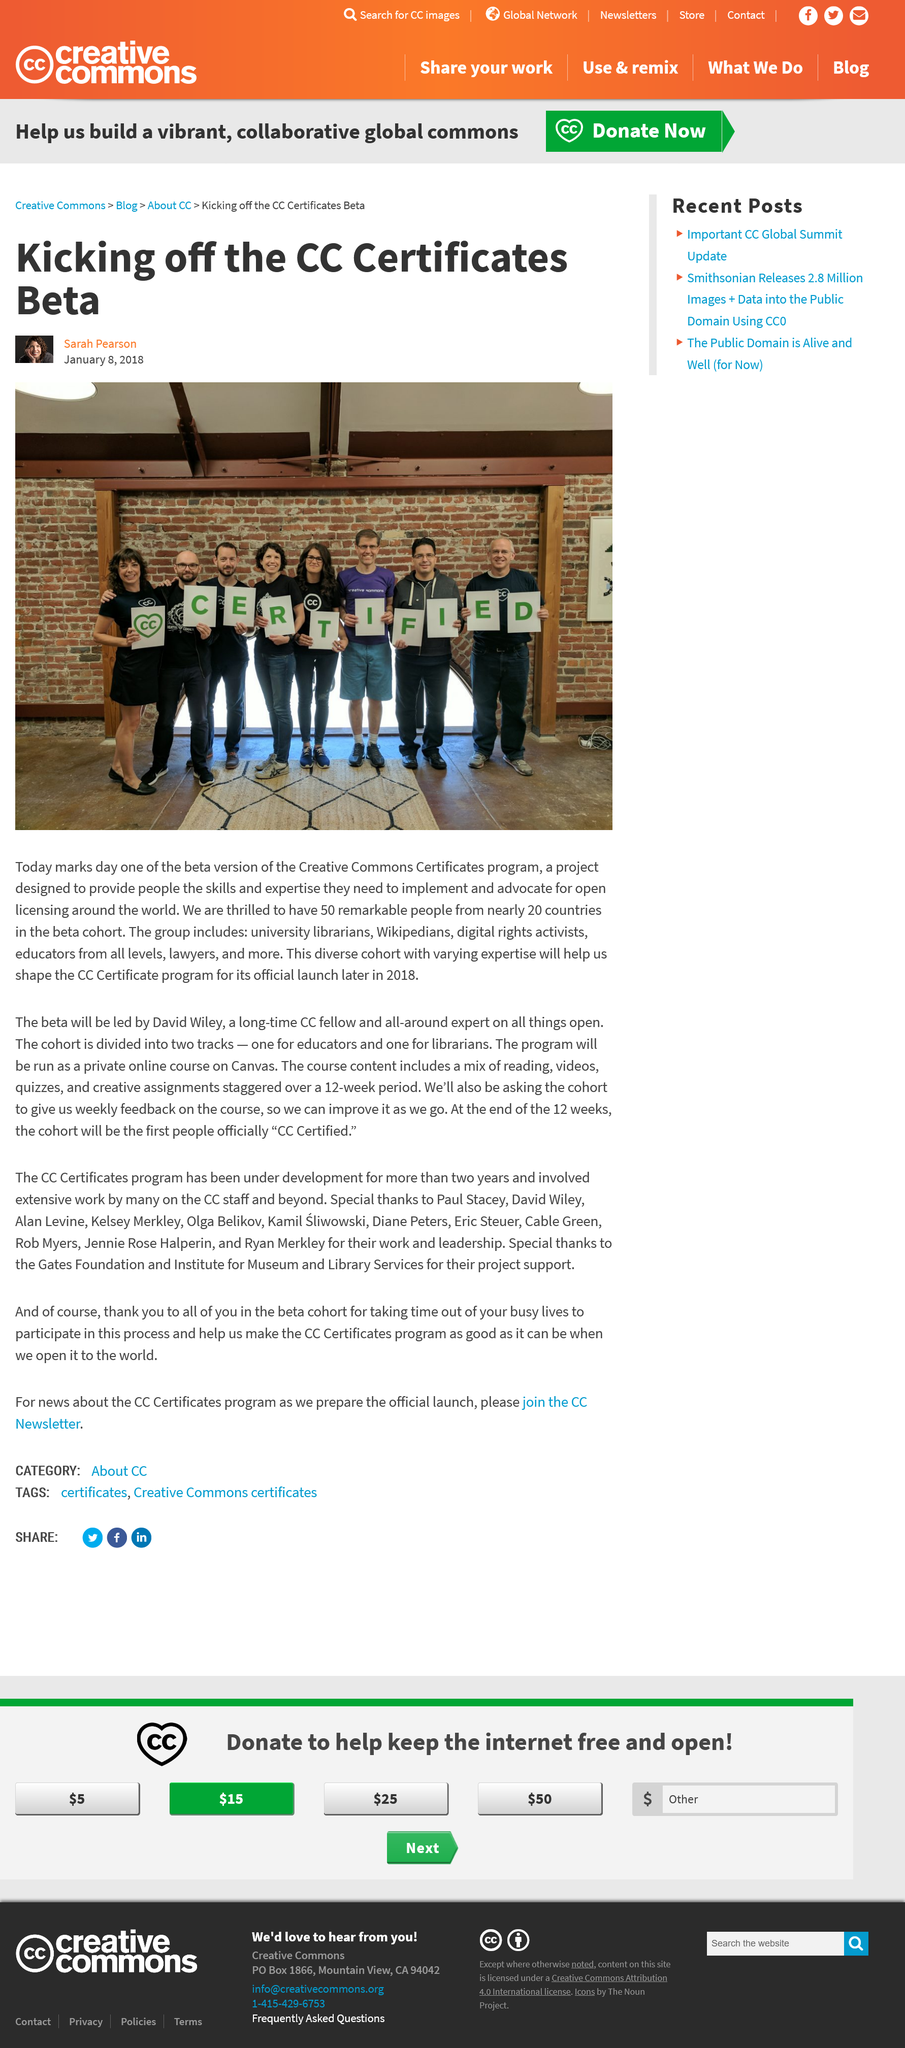Outline some significant characteristics in this image. The Creative Commons Certificates program began on January 8, 2018, and the beta version started on that day. There are 50 people in the beta cohort. There are 8 individuals in the photograph for the CC Certificates Beta. 